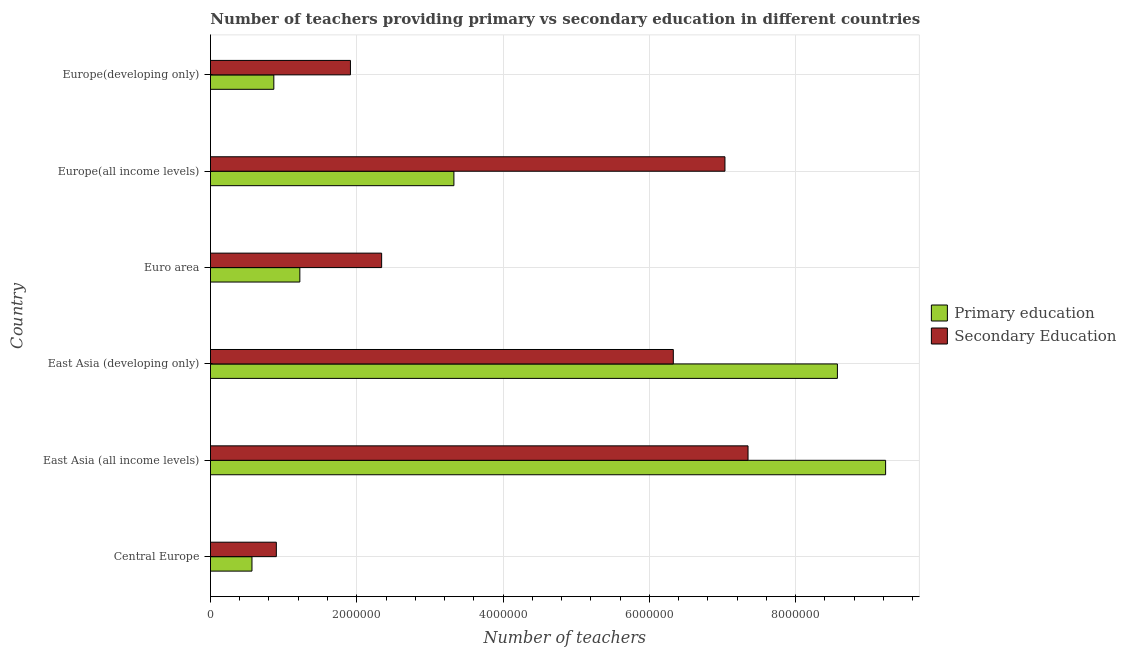How many groups of bars are there?
Keep it short and to the point. 6. Are the number of bars on each tick of the Y-axis equal?
Provide a short and direct response. Yes. How many bars are there on the 1st tick from the bottom?
Your response must be concise. 2. What is the label of the 2nd group of bars from the top?
Your answer should be very brief. Europe(all income levels). What is the number of secondary teachers in Europe(developing only)?
Offer a very short reply. 1.91e+06. Across all countries, what is the maximum number of secondary teachers?
Give a very brief answer. 7.35e+06. Across all countries, what is the minimum number of primary teachers?
Your answer should be very brief. 5.67e+05. In which country was the number of primary teachers maximum?
Provide a succinct answer. East Asia (all income levels). In which country was the number of secondary teachers minimum?
Your response must be concise. Central Europe. What is the total number of primary teachers in the graph?
Offer a very short reply. 2.38e+07. What is the difference between the number of primary teachers in Central Europe and that in Europe(all income levels)?
Give a very brief answer. -2.76e+06. What is the difference between the number of secondary teachers in Euro area and the number of primary teachers in Europe(all income levels)?
Provide a short and direct response. -9.88e+05. What is the average number of secondary teachers per country?
Make the answer very short. 4.31e+06. What is the difference between the number of secondary teachers and number of primary teachers in East Asia (developing only)?
Your answer should be very brief. -2.24e+06. What is the ratio of the number of secondary teachers in Central Europe to that in Europe(all income levels)?
Your answer should be very brief. 0.13. Is the number of secondary teachers in East Asia (all income levels) less than that in Euro area?
Provide a succinct answer. No. Is the difference between the number of primary teachers in Central Europe and Europe(all income levels) greater than the difference between the number of secondary teachers in Central Europe and Europe(all income levels)?
Your answer should be very brief. Yes. What is the difference between the highest and the second highest number of secondary teachers?
Your response must be concise. 3.16e+05. What is the difference between the highest and the lowest number of primary teachers?
Provide a short and direct response. 8.66e+06. In how many countries, is the number of primary teachers greater than the average number of primary teachers taken over all countries?
Provide a succinct answer. 2. Is the sum of the number of secondary teachers in East Asia (all income levels) and Europe(developing only) greater than the maximum number of primary teachers across all countries?
Keep it short and to the point. Yes. What does the 1st bar from the top in Europe(developing only) represents?
Provide a short and direct response. Secondary Education. What does the 2nd bar from the bottom in Central Europe represents?
Provide a short and direct response. Secondary Education. How many bars are there?
Make the answer very short. 12. Are all the bars in the graph horizontal?
Provide a short and direct response. Yes. How many countries are there in the graph?
Offer a terse response. 6. Are the values on the major ticks of X-axis written in scientific E-notation?
Ensure brevity in your answer.  No. What is the title of the graph?
Keep it short and to the point. Number of teachers providing primary vs secondary education in different countries. What is the label or title of the X-axis?
Offer a terse response. Number of teachers. What is the label or title of the Y-axis?
Keep it short and to the point. Country. What is the Number of teachers in Primary education in Central Europe?
Your answer should be very brief. 5.67e+05. What is the Number of teachers in Secondary Education in Central Europe?
Provide a succinct answer. 9.01e+05. What is the Number of teachers in Primary education in East Asia (all income levels)?
Give a very brief answer. 9.23e+06. What is the Number of teachers in Secondary Education in East Asia (all income levels)?
Your answer should be very brief. 7.35e+06. What is the Number of teachers of Primary education in East Asia (developing only)?
Give a very brief answer. 8.57e+06. What is the Number of teachers in Secondary Education in East Asia (developing only)?
Offer a terse response. 6.33e+06. What is the Number of teachers in Primary education in Euro area?
Ensure brevity in your answer.  1.22e+06. What is the Number of teachers in Secondary Education in Euro area?
Ensure brevity in your answer.  2.34e+06. What is the Number of teachers of Primary education in Europe(all income levels)?
Ensure brevity in your answer.  3.33e+06. What is the Number of teachers of Secondary Education in Europe(all income levels)?
Make the answer very short. 7.03e+06. What is the Number of teachers in Primary education in Europe(developing only)?
Ensure brevity in your answer.  8.66e+05. What is the Number of teachers of Secondary Education in Europe(developing only)?
Provide a short and direct response. 1.91e+06. Across all countries, what is the maximum Number of teachers in Primary education?
Offer a terse response. 9.23e+06. Across all countries, what is the maximum Number of teachers in Secondary Education?
Your answer should be compact. 7.35e+06. Across all countries, what is the minimum Number of teachers in Primary education?
Offer a terse response. 5.67e+05. Across all countries, what is the minimum Number of teachers in Secondary Education?
Provide a succinct answer. 9.01e+05. What is the total Number of teachers in Primary education in the graph?
Offer a terse response. 2.38e+07. What is the total Number of teachers of Secondary Education in the graph?
Provide a succinct answer. 2.59e+07. What is the difference between the Number of teachers in Primary education in Central Europe and that in East Asia (all income levels)?
Offer a very short reply. -8.66e+06. What is the difference between the Number of teachers in Secondary Education in Central Europe and that in East Asia (all income levels)?
Provide a succinct answer. -6.45e+06. What is the difference between the Number of teachers of Primary education in Central Europe and that in East Asia (developing only)?
Your answer should be very brief. -8.00e+06. What is the difference between the Number of teachers in Secondary Education in Central Europe and that in East Asia (developing only)?
Offer a very short reply. -5.43e+06. What is the difference between the Number of teachers of Primary education in Central Europe and that in Euro area?
Your answer should be compact. -6.54e+05. What is the difference between the Number of teachers of Secondary Education in Central Europe and that in Euro area?
Your answer should be very brief. -1.44e+06. What is the difference between the Number of teachers in Primary education in Central Europe and that in Europe(all income levels)?
Give a very brief answer. -2.76e+06. What is the difference between the Number of teachers of Secondary Education in Central Europe and that in Europe(all income levels)?
Provide a succinct answer. -6.13e+06. What is the difference between the Number of teachers of Primary education in Central Europe and that in Europe(developing only)?
Make the answer very short. -2.99e+05. What is the difference between the Number of teachers of Secondary Education in Central Europe and that in Europe(developing only)?
Keep it short and to the point. -1.01e+06. What is the difference between the Number of teachers in Primary education in East Asia (all income levels) and that in East Asia (developing only)?
Your response must be concise. 6.59e+05. What is the difference between the Number of teachers of Secondary Education in East Asia (all income levels) and that in East Asia (developing only)?
Your response must be concise. 1.02e+06. What is the difference between the Number of teachers of Primary education in East Asia (all income levels) and that in Euro area?
Your answer should be compact. 8.01e+06. What is the difference between the Number of teachers in Secondary Education in East Asia (all income levels) and that in Euro area?
Your answer should be very brief. 5.01e+06. What is the difference between the Number of teachers in Primary education in East Asia (all income levels) and that in Europe(all income levels)?
Ensure brevity in your answer.  5.90e+06. What is the difference between the Number of teachers of Secondary Education in East Asia (all income levels) and that in Europe(all income levels)?
Your answer should be compact. 3.16e+05. What is the difference between the Number of teachers of Primary education in East Asia (all income levels) and that in Europe(developing only)?
Your answer should be very brief. 8.36e+06. What is the difference between the Number of teachers in Secondary Education in East Asia (all income levels) and that in Europe(developing only)?
Offer a terse response. 5.44e+06. What is the difference between the Number of teachers of Primary education in East Asia (developing only) and that in Euro area?
Your answer should be compact. 7.35e+06. What is the difference between the Number of teachers in Secondary Education in East Asia (developing only) and that in Euro area?
Make the answer very short. 3.99e+06. What is the difference between the Number of teachers of Primary education in East Asia (developing only) and that in Europe(all income levels)?
Your response must be concise. 5.24e+06. What is the difference between the Number of teachers of Secondary Education in East Asia (developing only) and that in Europe(all income levels)?
Provide a succinct answer. -7.06e+05. What is the difference between the Number of teachers in Primary education in East Asia (developing only) and that in Europe(developing only)?
Your answer should be very brief. 7.71e+06. What is the difference between the Number of teachers in Secondary Education in East Asia (developing only) and that in Europe(developing only)?
Ensure brevity in your answer.  4.41e+06. What is the difference between the Number of teachers in Primary education in Euro area and that in Europe(all income levels)?
Your response must be concise. -2.11e+06. What is the difference between the Number of teachers in Secondary Education in Euro area and that in Europe(all income levels)?
Keep it short and to the point. -4.69e+06. What is the difference between the Number of teachers of Primary education in Euro area and that in Europe(developing only)?
Your answer should be very brief. 3.56e+05. What is the difference between the Number of teachers of Secondary Education in Euro area and that in Europe(developing only)?
Your response must be concise. 4.27e+05. What is the difference between the Number of teachers in Primary education in Europe(all income levels) and that in Europe(developing only)?
Offer a terse response. 2.46e+06. What is the difference between the Number of teachers in Secondary Education in Europe(all income levels) and that in Europe(developing only)?
Offer a terse response. 5.12e+06. What is the difference between the Number of teachers in Primary education in Central Europe and the Number of teachers in Secondary Education in East Asia (all income levels)?
Provide a succinct answer. -6.78e+06. What is the difference between the Number of teachers of Primary education in Central Europe and the Number of teachers of Secondary Education in East Asia (developing only)?
Offer a terse response. -5.76e+06. What is the difference between the Number of teachers in Primary education in Central Europe and the Number of teachers in Secondary Education in Euro area?
Ensure brevity in your answer.  -1.77e+06. What is the difference between the Number of teachers of Primary education in Central Europe and the Number of teachers of Secondary Education in Europe(all income levels)?
Offer a very short reply. -6.47e+06. What is the difference between the Number of teachers of Primary education in Central Europe and the Number of teachers of Secondary Education in Europe(developing only)?
Your answer should be compact. -1.35e+06. What is the difference between the Number of teachers in Primary education in East Asia (all income levels) and the Number of teachers in Secondary Education in East Asia (developing only)?
Your response must be concise. 2.90e+06. What is the difference between the Number of teachers in Primary education in East Asia (all income levels) and the Number of teachers in Secondary Education in Euro area?
Make the answer very short. 6.89e+06. What is the difference between the Number of teachers in Primary education in East Asia (all income levels) and the Number of teachers in Secondary Education in Europe(all income levels)?
Offer a very short reply. 2.20e+06. What is the difference between the Number of teachers in Primary education in East Asia (all income levels) and the Number of teachers in Secondary Education in Europe(developing only)?
Give a very brief answer. 7.32e+06. What is the difference between the Number of teachers in Primary education in East Asia (developing only) and the Number of teachers in Secondary Education in Euro area?
Provide a short and direct response. 6.23e+06. What is the difference between the Number of teachers in Primary education in East Asia (developing only) and the Number of teachers in Secondary Education in Europe(all income levels)?
Your answer should be compact. 1.54e+06. What is the difference between the Number of teachers of Primary education in East Asia (developing only) and the Number of teachers of Secondary Education in Europe(developing only)?
Provide a short and direct response. 6.66e+06. What is the difference between the Number of teachers of Primary education in Euro area and the Number of teachers of Secondary Education in Europe(all income levels)?
Provide a short and direct response. -5.81e+06. What is the difference between the Number of teachers in Primary education in Euro area and the Number of teachers in Secondary Education in Europe(developing only)?
Provide a succinct answer. -6.92e+05. What is the difference between the Number of teachers of Primary education in Europe(all income levels) and the Number of teachers of Secondary Education in Europe(developing only)?
Your answer should be compact. 1.41e+06. What is the average Number of teachers of Primary education per country?
Make the answer very short. 3.96e+06. What is the average Number of teachers of Secondary Education per country?
Make the answer very short. 4.31e+06. What is the difference between the Number of teachers in Primary education and Number of teachers in Secondary Education in Central Europe?
Your answer should be very brief. -3.33e+05. What is the difference between the Number of teachers of Primary education and Number of teachers of Secondary Education in East Asia (all income levels)?
Keep it short and to the point. 1.88e+06. What is the difference between the Number of teachers in Primary education and Number of teachers in Secondary Education in East Asia (developing only)?
Offer a very short reply. 2.24e+06. What is the difference between the Number of teachers in Primary education and Number of teachers in Secondary Education in Euro area?
Keep it short and to the point. -1.12e+06. What is the difference between the Number of teachers of Primary education and Number of teachers of Secondary Education in Europe(all income levels)?
Your answer should be compact. -3.71e+06. What is the difference between the Number of teachers in Primary education and Number of teachers in Secondary Education in Europe(developing only)?
Your answer should be very brief. -1.05e+06. What is the ratio of the Number of teachers of Primary education in Central Europe to that in East Asia (all income levels)?
Make the answer very short. 0.06. What is the ratio of the Number of teachers in Secondary Education in Central Europe to that in East Asia (all income levels)?
Offer a terse response. 0.12. What is the ratio of the Number of teachers in Primary education in Central Europe to that in East Asia (developing only)?
Your answer should be compact. 0.07. What is the ratio of the Number of teachers of Secondary Education in Central Europe to that in East Asia (developing only)?
Ensure brevity in your answer.  0.14. What is the ratio of the Number of teachers in Primary education in Central Europe to that in Euro area?
Your answer should be compact. 0.46. What is the ratio of the Number of teachers of Secondary Education in Central Europe to that in Euro area?
Make the answer very short. 0.38. What is the ratio of the Number of teachers of Primary education in Central Europe to that in Europe(all income levels)?
Offer a terse response. 0.17. What is the ratio of the Number of teachers in Secondary Education in Central Europe to that in Europe(all income levels)?
Provide a short and direct response. 0.13. What is the ratio of the Number of teachers of Primary education in Central Europe to that in Europe(developing only)?
Offer a terse response. 0.66. What is the ratio of the Number of teachers of Secondary Education in Central Europe to that in Europe(developing only)?
Ensure brevity in your answer.  0.47. What is the ratio of the Number of teachers in Secondary Education in East Asia (all income levels) to that in East Asia (developing only)?
Make the answer very short. 1.16. What is the ratio of the Number of teachers in Primary education in East Asia (all income levels) to that in Euro area?
Offer a very short reply. 7.55. What is the ratio of the Number of teachers in Secondary Education in East Asia (all income levels) to that in Euro area?
Give a very brief answer. 3.14. What is the ratio of the Number of teachers in Primary education in East Asia (all income levels) to that in Europe(all income levels)?
Offer a terse response. 2.77. What is the ratio of the Number of teachers of Secondary Education in East Asia (all income levels) to that in Europe(all income levels)?
Give a very brief answer. 1.04. What is the ratio of the Number of teachers of Primary education in East Asia (all income levels) to that in Europe(developing only)?
Provide a short and direct response. 10.66. What is the ratio of the Number of teachers in Secondary Education in East Asia (all income levels) to that in Europe(developing only)?
Your answer should be very brief. 3.84. What is the ratio of the Number of teachers in Primary education in East Asia (developing only) to that in Euro area?
Give a very brief answer. 7.02. What is the ratio of the Number of teachers in Secondary Education in East Asia (developing only) to that in Euro area?
Ensure brevity in your answer.  2.7. What is the ratio of the Number of teachers of Primary education in East Asia (developing only) to that in Europe(all income levels)?
Offer a terse response. 2.58. What is the ratio of the Number of teachers in Secondary Education in East Asia (developing only) to that in Europe(all income levels)?
Your answer should be compact. 0.9. What is the ratio of the Number of teachers of Primary education in East Asia (developing only) to that in Europe(developing only)?
Make the answer very short. 9.9. What is the ratio of the Number of teachers of Secondary Education in East Asia (developing only) to that in Europe(developing only)?
Provide a short and direct response. 3.31. What is the ratio of the Number of teachers of Primary education in Euro area to that in Europe(all income levels)?
Ensure brevity in your answer.  0.37. What is the ratio of the Number of teachers of Secondary Education in Euro area to that in Europe(all income levels)?
Your response must be concise. 0.33. What is the ratio of the Number of teachers in Primary education in Euro area to that in Europe(developing only)?
Your answer should be very brief. 1.41. What is the ratio of the Number of teachers in Secondary Education in Euro area to that in Europe(developing only)?
Provide a succinct answer. 1.22. What is the ratio of the Number of teachers in Primary education in Europe(all income levels) to that in Europe(developing only)?
Provide a short and direct response. 3.84. What is the ratio of the Number of teachers in Secondary Education in Europe(all income levels) to that in Europe(developing only)?
Your answer should be compact. 3.68. What is the difference between the highest and the second highest Number of teachers of Primary education?
Offer a very short reply. 6.59e+05. What is the difference between the highest and the second highest Number of teachers in Secondary Education?
Make the answer very short. 3.16e+05. What is the difference between the highest and the lowest Number of teachers in Primary education?
Keep it short and to the point. 8.66e+06. What is the difference between the highest and the lowest Number of teachers of Secondary Education?
Your answer should be very brief. 6.45e+06. 